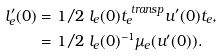Convert formula to latex. <formula><loc_0><loc_0><loc_500><loc_500>l _ { e } ^ { \prime } ( 0 ) & = 1 / 2 \ l _ { e } ( 0 ) t _ { e } ^ { \ t r a n s p } u ^ { \prime } ( 0 ) t _ { e } , \\ & = 1 / 2 \ l _ { e } ( 0 ) ^ { - 1 } \mu _ { e } ( u ^ { \prime } ( 0 ) ) .</formula> 